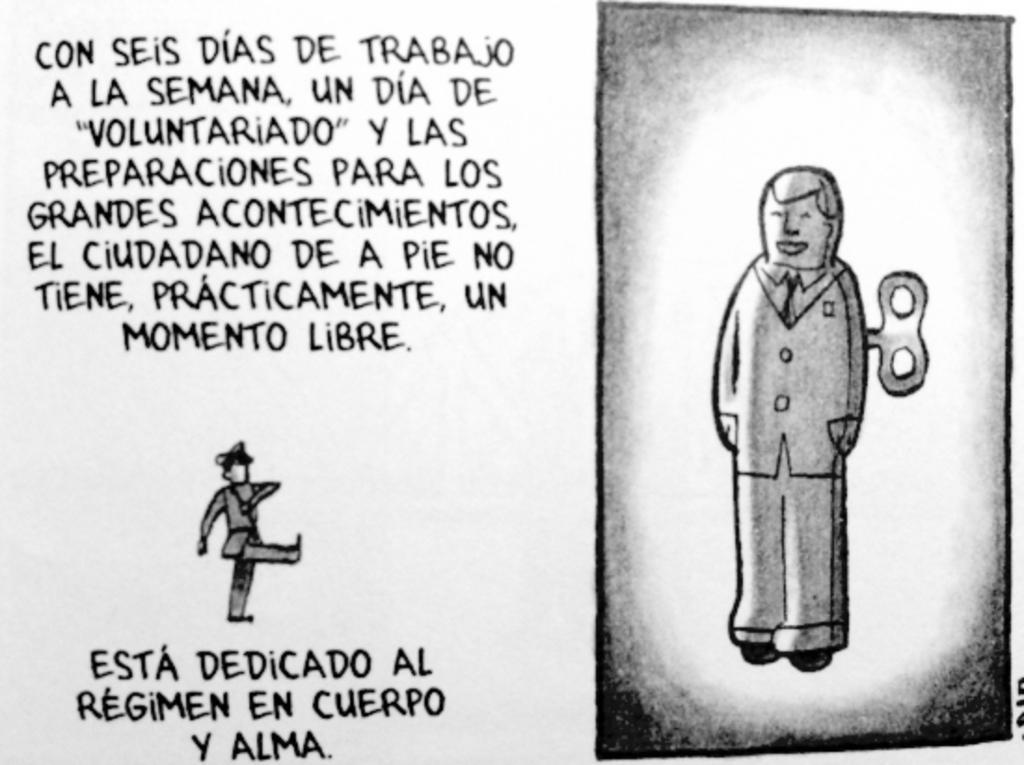Please provide a concise description of this image. In this image we can see two cartoons is drawn and some text written with black ink. 